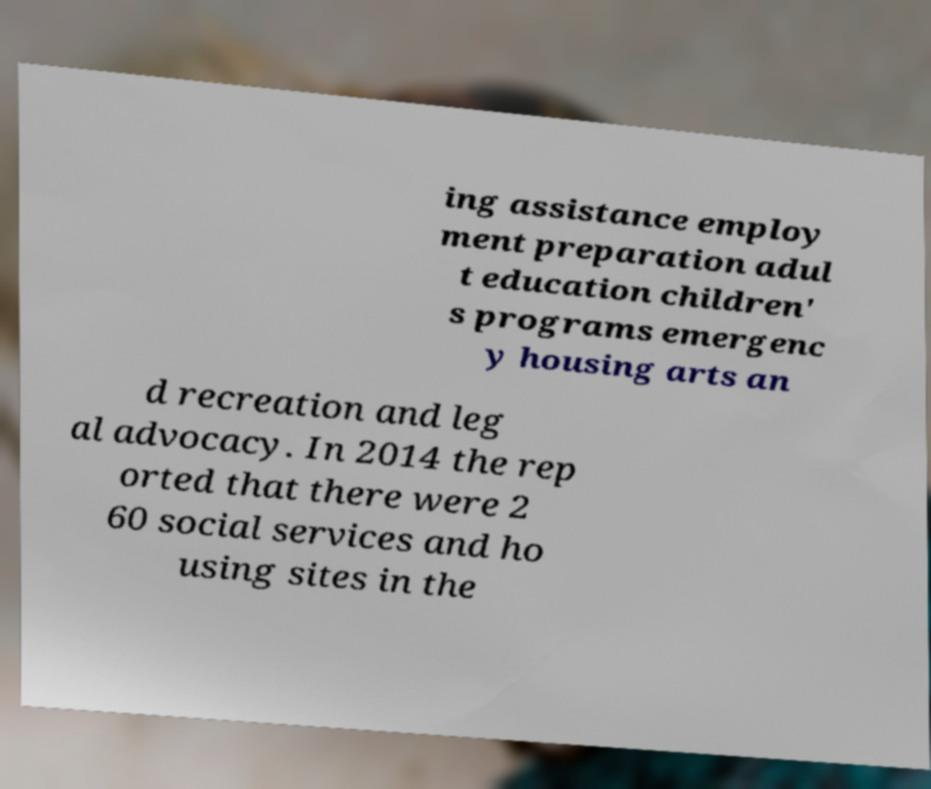Please identify and transcribe the text found in this image. ing assistance employ ment preparation adul t education children' s programs emergenc y housing arts an d recreation and leg al advocacy. In 2014 the rep orted that there were 2 60 social services and ho using sites in the 